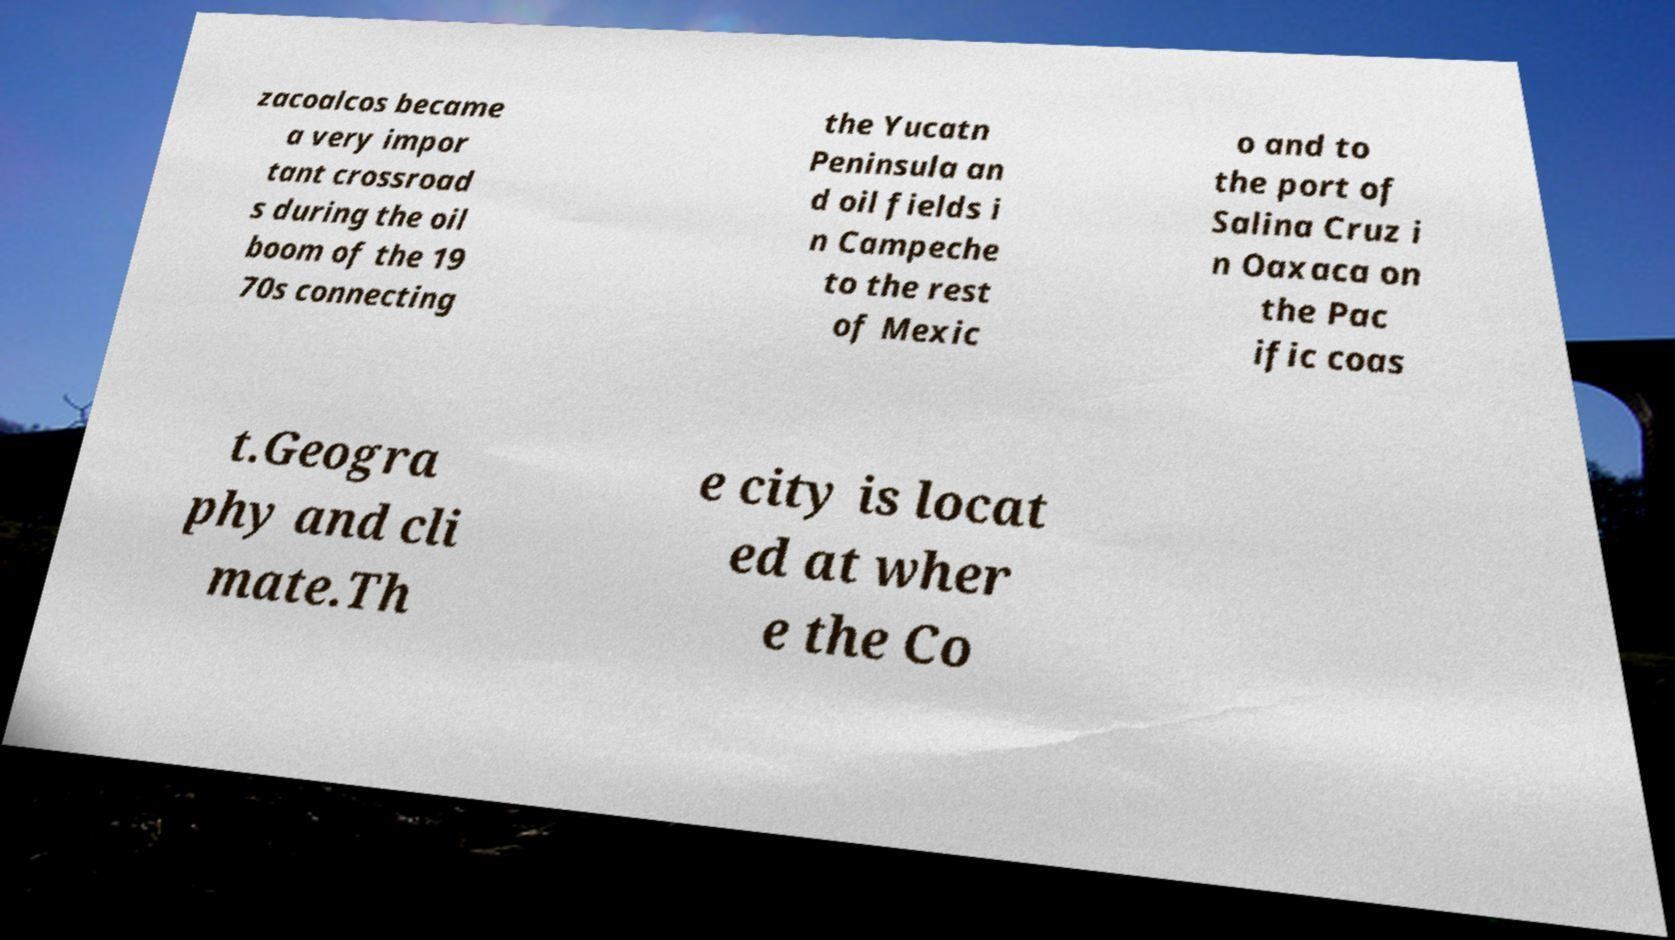For documentation purposes, I need the text within this image transcribed. Could you provide that? zacoalcos became a very impor tant crossroad s during the oil boom of the 19 70s connecting the Yucatn Peninsula an d oil fields i n Campeche to the rest of Mexic o and to the port of Salina Cruz i n Oaxaca on the Pac ific coas t.Geogra phy and cli mate.Th e city is locat ed at wher e the Co 